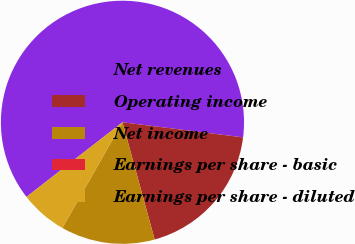<chart> <loc_0><loc_0><loc_500><loc_500><pie_chart><fcel>Net revenues<fcel>Operating income<fcel>Net income<fcel>Earnings per share - basic<fcel>Earnings per share - diluted<nl><fcel>62.5%<fcel>18.75%<fcel>12.5%<fcel>0.0%<fcel>6.25%<nl></chart> 